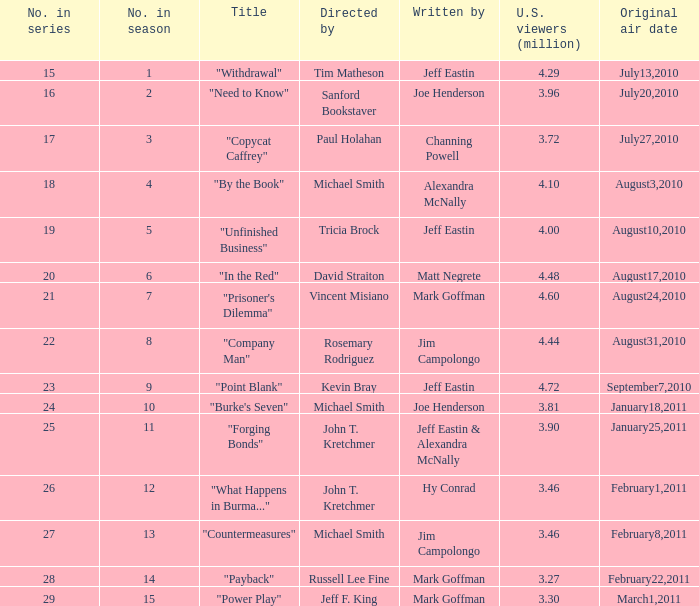How many millions of people in the US watched when Kevin Bray was director? 4.72. 